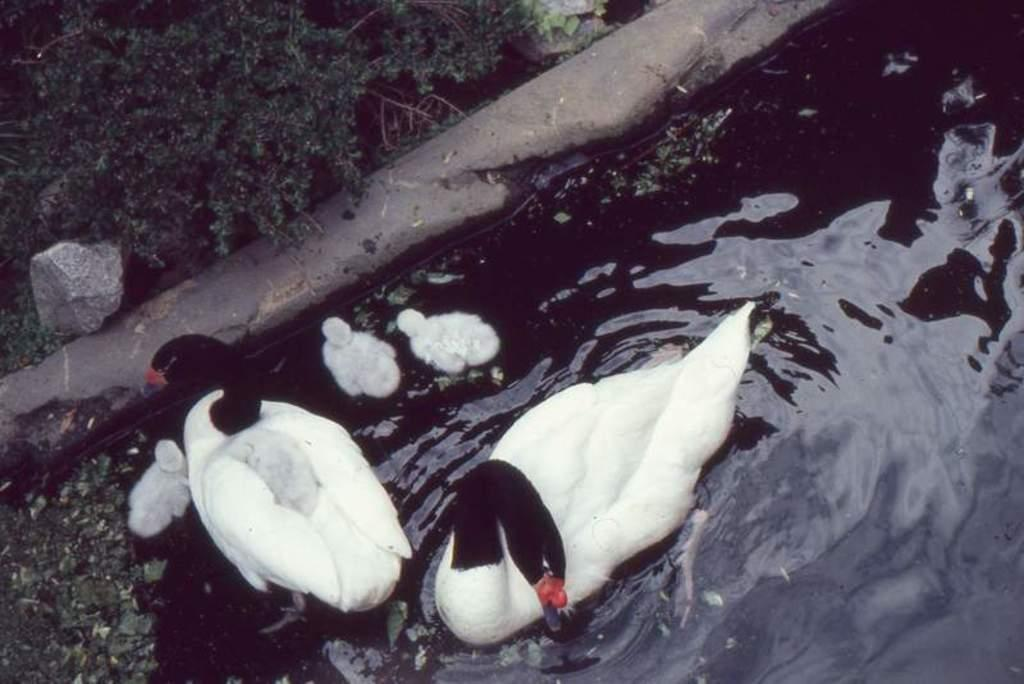What type of animals can be seen in the water in the image? There are ducks and ducklings in the water in the image. What is located near the water in the image? There is a stone near the water in the image. What else can be seen in the image besides the animals and stone? There are plants visible in the image. What decision does the frog make in the image? There is no frog present in the image, so no decision can be made by a frog. 